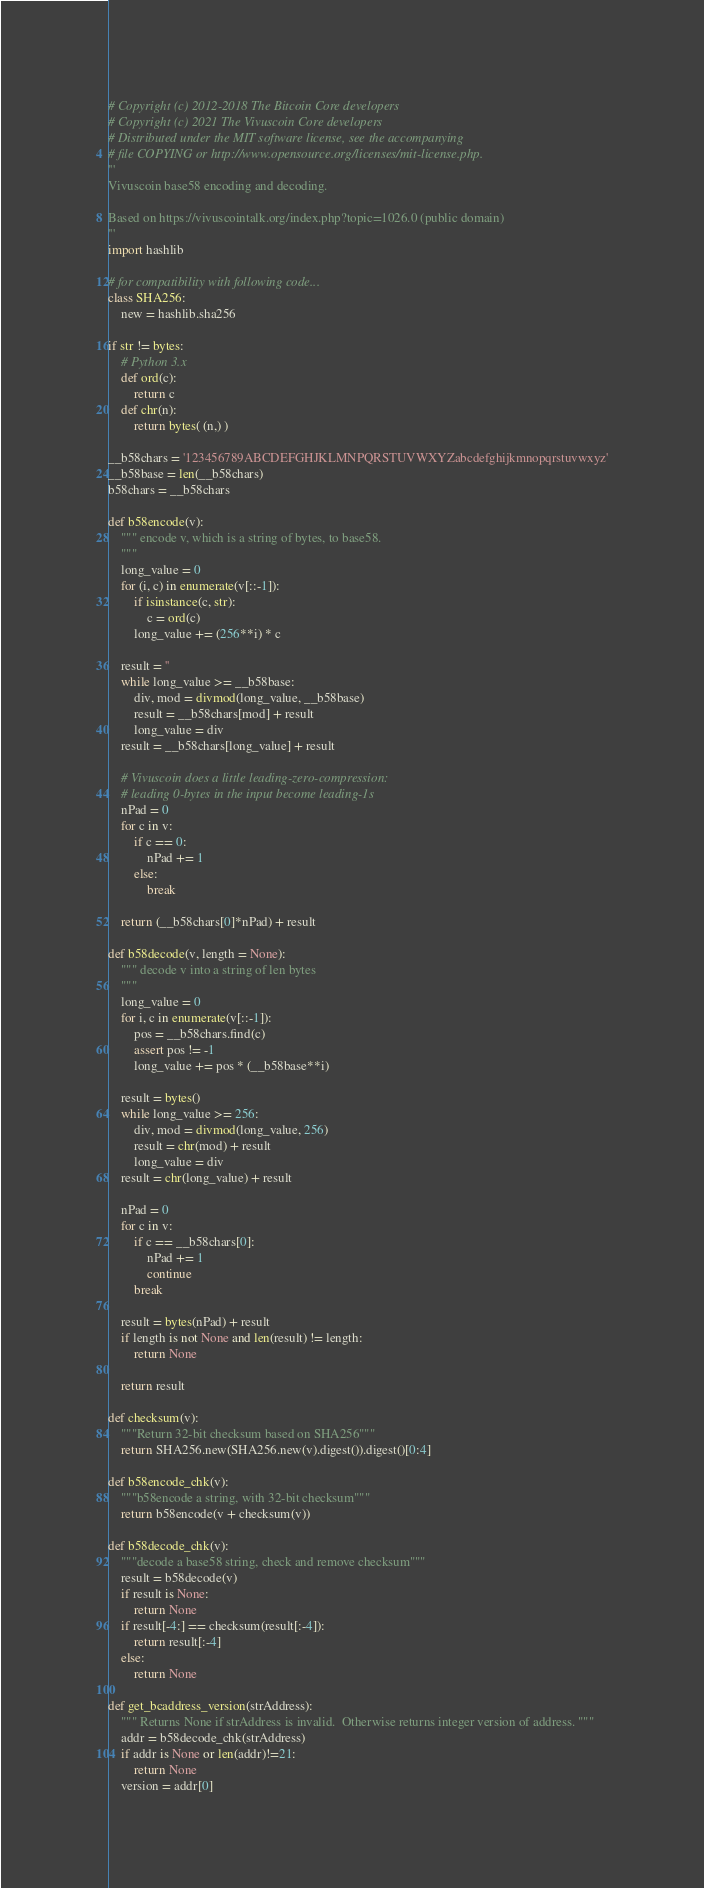Convert code to text. <code><loc_0><loc_0><loc_500><loc_500><_Python_># Copyright (c) 2012-2018 The Bitcoin Core developers
# Copyright (c) 2021 The Vivuscoin Core developers
# Distributed under the MIT software license, see the accompanying
# file COPYING or http://www.opensource.org/licenses/mit-license.php.
'''
Vivuscoin base58 encoding and decoding.

Based on https://vivuscointalk.org/index.php?topic=1026.0 (public domain)
'''
import hashlib

# for compatibility with following code...
class SHA256:
    new = hashlib.sha256

if str != bytes:
    # Python 3.x
    def ord(c):
        return c
    def chr(n):
        return bytes( (n,) )

__b58chars = '123456789ABCDEFGHJKLMNPQRSTUVWXYZabcdefghijkmnopqrstuvwxyz'
__b58base = len(__b58chars)
b58chars = __b58chars

def b58encode(v):
    """ encode v, which is a string of bytes, to base58.
    """
    long_value = 0
    for (i, c) in enumerate(v[::-1]):
        if isinstance(c, str):
            c = ord(c)
        long_value += (256**i) * c

    result = ''
    while long_value >= __b58base:
        div, mod = divmod(long_value, __b58base)
        result = __b58chars[mod] + result
        long_value = div
    result = __b58chars[long_value] + result

    # Vivuscoin does a little leading-zero-compression:
    # leading 0-bytes in the input become leading-1s
    nPad = 0
    for c in v:
        if c == 0:
            nPad += 1
        else:
            break

    return (__b58chars[0]*nPad) + result

def b58decode(v, length = None):
    """ decode v into a string of len bytes
    """
    long_value = 0
    for i, c in enumerate(v[::-1]):
        pos = __b58chars.find(c)
        assert pos != -1
        long_value += pos * (__b58base**i)

    result = bytes()
    while long_value >= 256:
        div, mod = divmod(long_value, 256)
        result = chr(mod) + result
        long_value = div
    result = chr(long_value) + result

    nPad = 0
    for c in v:
        if c == __b58chars[0]:
            nPad += 1
            continue
        break

    result = bytes(nPad) + result
    if length is not None and len(result) != length:
        return None

    return result

def checksum(v):
    """Return 32-bit checksum based on SHA256"""
    return SHA256.new(SHA256.new(v).digest()).digest()[0:4]

def b58encode_chk(v):
    """b58encode a string, with 32-bit checksum"""
    return b58encode(v + checksum(v))

def b58decode_chk(v):
    """decode a base58 string, check and remove checksum"""
    result = b58decode(v)
    if result is None:
        return None
    if result[-4:] == checksum(result[:-4]):
        return result[:-4]
    else:
        return None

def get_bcaddress_version(strAddress):
    """ Returns None if strAddress is invalid.  Otherwise returns integer version of address. """
    addr = b58decode_chk(strAddress)
    if addr is None or len(addr)!=21:
        return None
    version = addr[0]</code> 